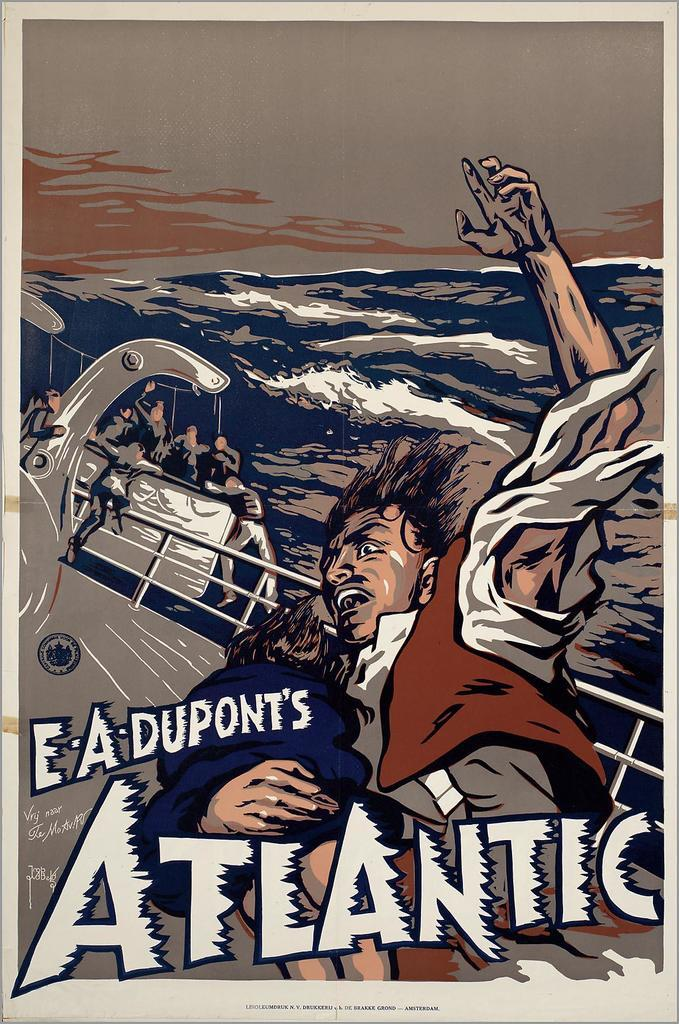<image>
Render a clear and concise summary of the photo. A poster for the 1929 E.A. Dupont film "Atlantic". 